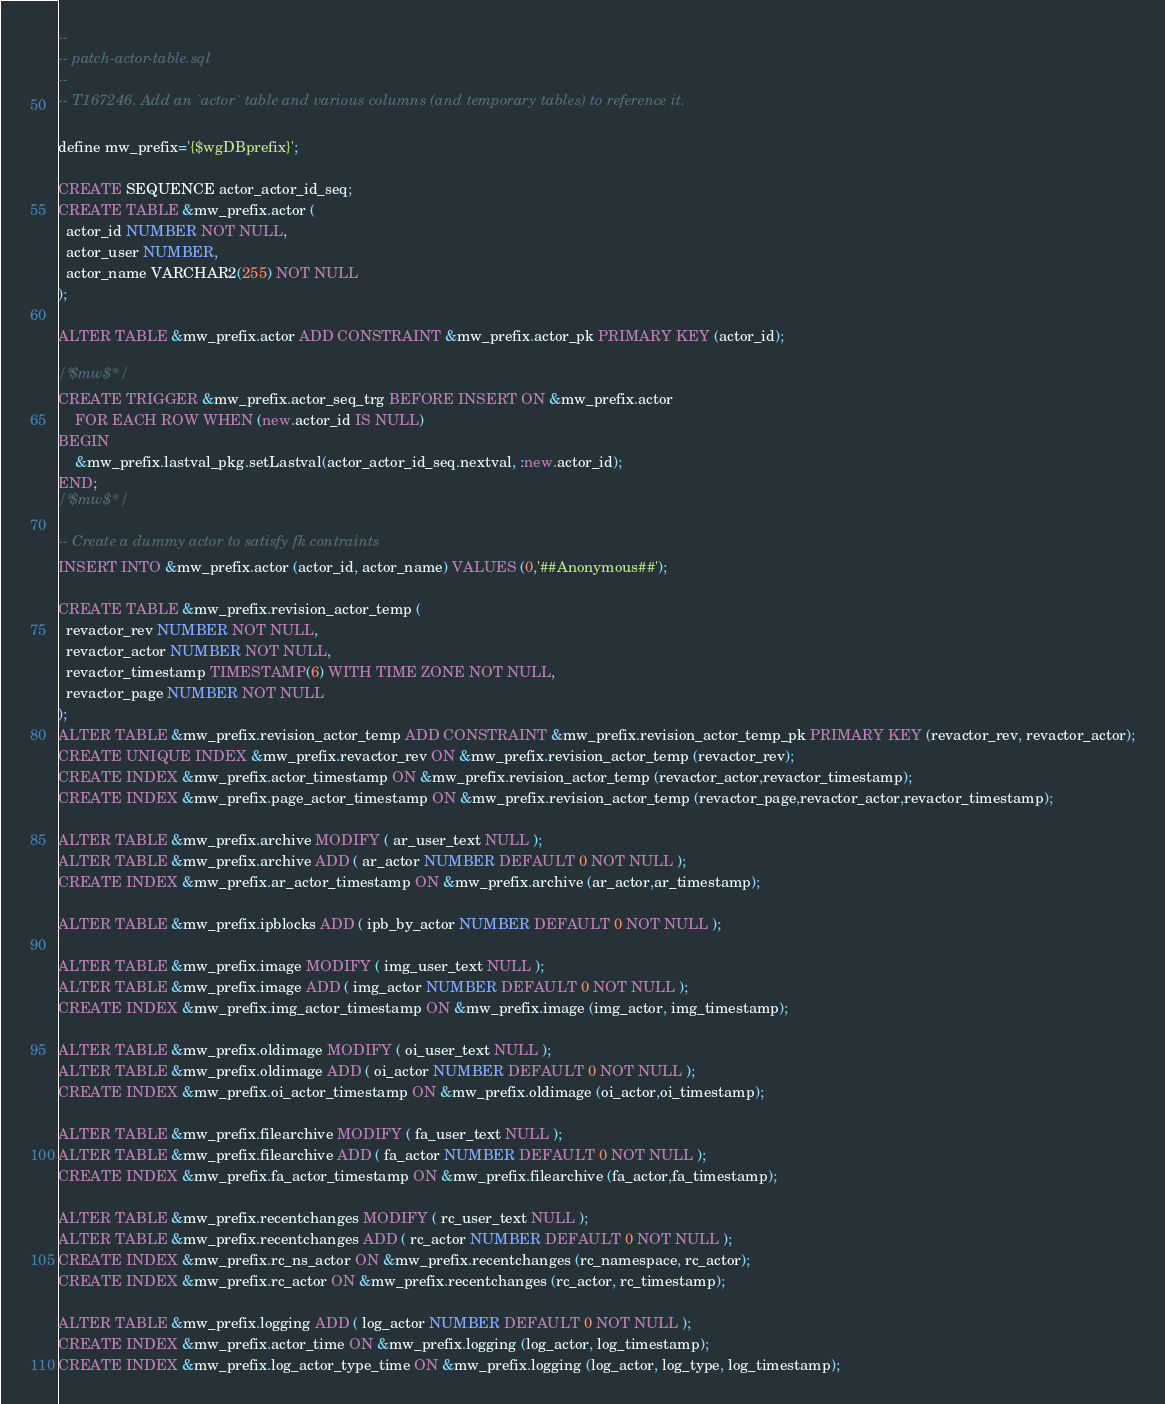Convert code to text. <code><loc_0><loc_0><loc_500><loc_500><_SQL_>--
-- patch-actor-table.sql
--
-- T167246. Add an `actor` table and various columns (and temporary tables) to reference it.

define mw_prefix='{$wgDBprefix}';

CREATE SEQUENCE actor_actor_id_seq;
CREATE TABLE &mw_prefix.actor (
  actor_id NUMBER NOT NULL,
  actor_user NUMBER,
  actor_name VARCHAR2(255) NOT NULL
);

ALTER TABLE &mw_prefix.actor ADD CONSTRAINT &mw_prefix.actor_pk PRIMARY KEY (actor_id);

/*$mw$*/
CREATE TRIGGER &mw_prefix.actor_seq_trg BEFORE INSERT ON &mw_prefix.actor
	FOR EACH ROW WHEN (new.actor_id IS NULL)
BEGIN
	&mw_prefix.lastval_pkg.setLastval(actor_actor_id_seq.nextval, :new.actor_id);
END;
/*$mw$*/

-- Create a dummy actor to satisfy fk contraints
INSERT INTO &mw_prefix.actor (actor_id, actor_name) VALUES (0,'##Anonymous##');

CREATE TABLE &mw_prefix.revision_actor_temp (
  revactor_rev NUMBER NOT NULL,
  revactor_actor NUMBER NOT NULL,
  revactor_timestamp TIMESTAMP(6) WITH TIME ZONE NOT NULL,
  revactor_page NUMBER NOT NULL
);
ALTER TABLE &mw_prefix.revision_actor_temp ADD CONSTRAINT &mw_prefix.revision_actor_temp_pk PRIMARY KEY (revactor_rev, revactor_actor);
CREATE UNIQUE INDEX &mw_prefix.revactor_rev ON &mw_prefix.revision_actor_temp (revactor_rev);
CREATE INDEX &mw_prefix.actor_timestamp ON &mw_prefix.revision_actor_temp (revactor_actor,revactor_timestamp);
CREATE INDEX &mw_prefix.page_actor_timestamp ON &mw_prefix.revision_actor_temp (revactor_page,revactor_actor,revactor_timestamp);

ALTER TABLE &mw_prefix.archive MODIFY ( ar_user_text NULL );
ALTER TABLE &mw_prefix.archive ADD ( ar_actor NUMBER DEFAULT 0 NOT NULL );
CREATE INDEX &mw_prefix.ar_actor_timestamp ON &mw_prefix.archive (ar_actor,ar_timestamp);

ALTER TABLE &mw_prefix.ipblocks ADD ( ipb_by_actor NUMBER DEFAULT 0 NOT NULL );

ALTER TABLE &mw_prefix.image MODIFY ( img_user_text NULL );
ALTER TABLE &mw_prefix.image ADD ( img_actor NUMBER DEFAULT 0 NOT NULL );
CREATE INDEX &mw_prefix.img_actor_timestamp ON &mw_prefix.image (img_actor, img_timestamp);

ALTER TABLE &mw_prefix.oldimage MODIFY ( oi_user_text NULL );
ALTER TABLE &mw_prefix.oldimage ADD ( oi_actor NUMBER DEFAULT 0 NOT NULL );
CREATE INDEX &mw_prefix.oi_actor_timestamp ON &mw_prefix.oldimage (oi_actor,oi_timestamp);

ALTER TABLE &mw_prefix.filearchive MODIFY ( fa_user_text NULL );
ALTER TABLE &mw_prefix.filearchive ADD ( fa_actor NUMBER DEFAULT 0 NOT NULL );
CREATE INDEX &mw_prefix.fa_actor_timestamp ON &mw_prefix.filearchive (fa_actor,fa_timestamp);

ALTER TABLE &mw_prefix.recentchanges MODIFY ( rc_user_text NULL );
ALTER TABLE &mw_prefix.recentchanges ADD ( rc_actor NUMBER DEFAULT 0 NOT NULL );
CREATE INDEX &mw_prefix.rc_ns_actor ON &mw_prefix.recentchanges (rc_namespace, rc_actor);
CREATE INDEX &mw_prefix.rc_actor ON &mw_prefix.recentchanges (rc_actor, rc_timestamp);

ALTER TABLE &mw_prefix.logging ADD ( log_actor NUMBER DEFAULT 0 NOT NULL );
CREATE INDEX &mw_prefix.actor_time ON &mw_prefix.logging (log_actor, log_timestamp);
CREATE INDEX &mw_prefix.log_actor_type_time ON &mw_prefix.logging (log_actor, log_type, log_timestamp);
</code> 